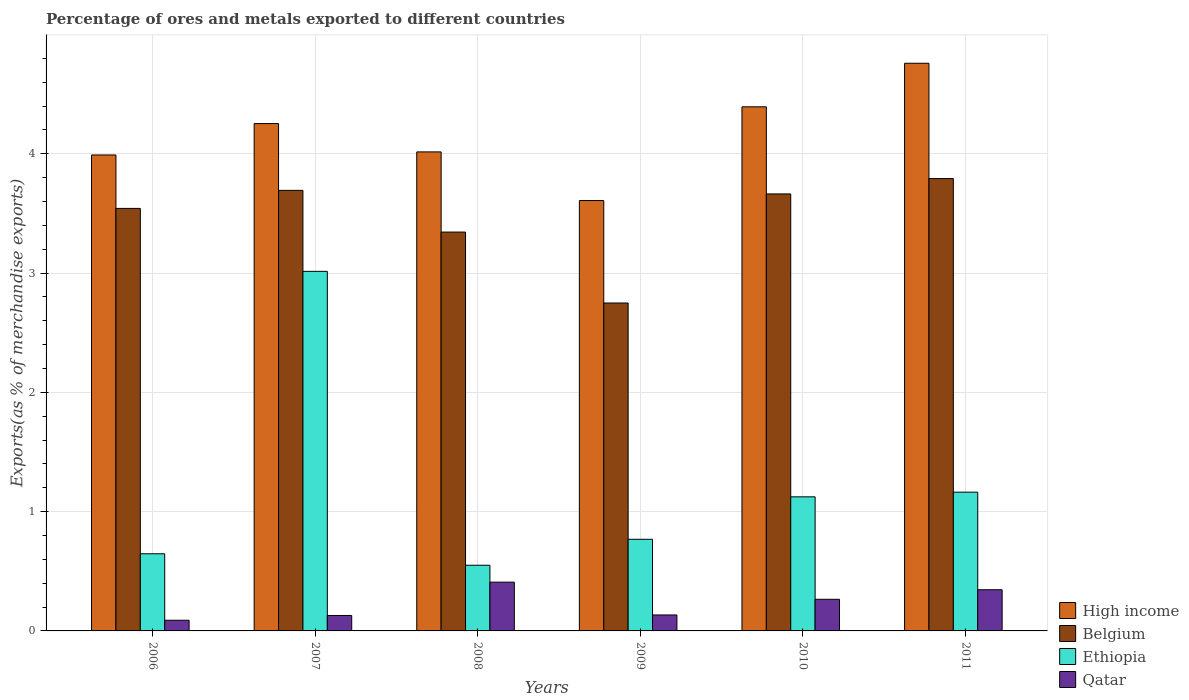Are the number of bars per tick equal to the number of legend labels?
Offer a terse response. Yes. How many bars are there on the 6th tick from the left?
Keep it short and to the point. 4. In how many cases, is the number of bars for a given year not equal to the number of legend labels?
Give a very brief answer. 0. What is the percentage of exports to different countries in High income in 2009?
Offer a very short reply. 3.61. Across all years, what is the maximum percentage of exports to different countries in High income?
Provide a succinct answer. 4.76. Across all years, what is the minimum percentage of exports to different countries in Belgium?
Your answer should be very brief. 2.75. What is the total percentage of exports to different countries in Belgium in the graph?
Give a very brief answer. 20.78. What is the difference between the percentage of exports to different countries in High income in 2006 and that in 2009?
Make the answer very short. 0.38. What is the difference between the percentage of exports to different countries in Belgium in 2007 and the percentage of exports to different countries in Ethiopia in 2006?
Offer a terse response. 3.05. What is the average percentage of exports to different countries in High income per year?
Ensure brevity in your answer.  4.17. In the year 2006, what is the difference between the percentage of exports to different countries in Qatar and percentage of exports to different countries in Ethiopia?
Provide a short and direct response. -0.56. In how many years, is the percentage of exports to different countries in Qatar greater than 4.2 %?
Your response must be concise. 0. What is the ratio of the percentage of exports to different countries in Belgium in 2007 to that in 2008?
Give a very brief answer. 1.1. Is the percentage of exports to different countries in Qatar in 2007 less than that in 2010?
Your answer should be very brief. Yes. What is the difference between the highest and the second highest percentage of exports to different countries in High income?
Ensure brevity in your answer.  0.37. What is the difference between the highest and the lowest percentage of exports to different countries in Ethiopia?
Your response must be concise. 2.46. What does the 2nd bar from the right in 2011 represents?
Provide a succinct answer. Ethiopia. Are all the bars in the graph horizontal?
Keep it short and to the point. No. How many years are there in the graph?
Your response must be concise. 6. What is the difference between two consecutive major ticks on the Y-axis?
Provide a succinct answer. 1. Are the values on the major ticks of Y-axis written in scientific E-notation?
Provide a succinct answer. No. Does the graph contain any zero values?
Give a very brief answer. No. How are the legend labels stacked?
Keep it short and to the point. Vertical. What is the title of the graph?
Ensure brevity in your answer.  Percentage of ores and metals exported to different countries. What is the label or title of the X-axis?
Give a very brief answer. Years. What is the label or title of the Y-axis?
Offer a terse response. Exports(as % of merchandise exports). What is the Exports(as % of merchandise exports) in High income in 2006?
Your response must be concise. 3.99. What is the Exports(as % of merchandise exports) of Belgium in 2006?
Offer a very short reply. 3.54. What is the Exports(as % of merchandise exports) of Ethiopia in 2006?
Your response must be concise. 0.65. What is the Exports(as % of merchandise exports) in Qatar in 2006?
Your response must be concise. 0.09. What is the Exports(as % of merchandise exports) of High income in 2007?
Offer a very short reply. 4.25. What is the Exports(as % of merchandise exports) of Belgium in 2007?
Your answer should be compact. 3.69. What is the Exports(as % of merchandise exports) in Ethiopia in 2007?
Offer a terse response. 3.01. What is the Exports(as % of merchandise exports) in Qatar in 2007?
Your answer should be compact. 0.13. What is the Exports(as % of merchandise exports) in High income in 2008?
Offer a very short reply. 4.02. What is the Exports(as % of merchandise exports) of Belgium in 2008?
Give a very brief answer. 3.34. What is the Exports(as % of merchandise exports) in Ethiopia in 2008?
Give a very brief answer. 0.55. What is the Exports(as % of merchandise exports) in Qatar in 2008?
Provide a succinct answer. 0.41. What is the Exports(as % of merchandise exports) in High income in 2009?
Keep it short and to the point. 3.61. What is the Exports(as % of merchandise exports) in Belgium in 2009?
Provide a short and direct response. 2.75. What is the Exports(as % of merchandise exports) in Ethiopia in 2009?
Your answer should be compact. 0.77. What is the Exports(as % of merchandise exports) in Qatar in 2009?
Keep it short and to the point. 0.13. What is the Exports(as % of merchandise exports) of High income in 2010?
Provide a succinct answer. 4.39. What is the Exports(as % of merchandise exports) of Belgium in 2010?
Your answer should be compact. 3.66. What is the Exports(as % of merchandise exports) in Ethiopia in 2010?
Ensure brevity in your answer.  1.12. What is the Exports(as % of merchandise exports) in Qatar in 2010?
Offer a very short reply. 0.27. What is the Exports(as % of merchandise exports) in High income in 2011?
Make the answer very short. 4.76. What is the Exports(as % of merchandise exports) of Belgium in 2011?
Keep it short and to the point. 3.79. What is the Exports(as % of merchandise exports) of Ethiopia in 2011?
Give a very brief answer. 1.16. What is the Exports(as % of merchandise exports) of Qatar in 2011?
Ensure brevity in your answer.  0.35. Across all years, what is the maximum Exports(as % of merchandise exports) of High income?
Your answer should be very brief. 4.76. Across all years, what is the maximum Exports(as % of merchandise exports) of Belgium?
Provide a succinct answer. 3.79. Across all years, what is the maximum Exports(as % of merchandise exports) of Ethiopia?
Your answer should be compact. 3.01. Across all years, what is the maximum Exports(as % of merchandise exports) of Qatar?
Your answer should be very brief. 0.41. Across all years, what is the minimum Exports(as % of merchandise exports) of High income?
Give a very brief answer. 3.61. Across all years, what is the minimum Exports(as % of merchandise exports) of Belgium?
Give a very brief answer. 2.75. Across all years, what is the minimum Exports(as % of merchandise exports) in Ethiopia?
Your response must be concise. 0.55. Across all years, what is the minimum Exports(as % of merchandise exports) in Qatar?
Ensure brevity in your answer.  0.09. What is the total Exports(as % of merchandise exports) in High income in the graph?
Your answer should be compact. 25.02. What is the total Exports(as % of merchandise exports) of Belgium in the graph?
Keep it short and to the point. 20.78. What is the total Exports(as % of merchandise exports) in Ethiopia in the graph?
Provide a succinct answer. 7.27. What is the total Exports(as % of merchandise exports) in Qatar in the graph?
Make the answer very short. 1.37. What is the difference between the Exports(as % of merchandise exports) in High income in 2006 and that in 2007?
Offer a very short reply. -0.26. What is the difference between the Exports(as % of merchandise exports) in Belgium in 2006 and that in 2007?
Your response must be concise. -0.15. What is the difference between the Exports(as % of merchandise exports) in Ethiopia in 2006 and that in 2007?
Offer a very short reply. -2.37. What is the difference between the Exports(as % of merchandise exports) in Qatar in 2006 and that in 2007?
Provide a succinct answer. -0.04. What is the difference between the Exports(as % of merchandise exports) in High income in 2006 and that in 2008?
Your answer should be very brief. -0.03. What is the difference between the Exports(as % of merchandise exports) of Belgium in 2006 and that in 2008?
Your answer should be very brief. 0.2. What is the difference between the Exports(as % of merchandise exports) of Ethiopia in 2006 and that in 2008?
Provide a succinct answer. 0.1. What is the difference between the Exports(as % of merchandise exports) of Qatar in 2006 and that in 2008?
Provide a short and direct response. -0.32. What is the difference between the Exports(as % of merchandise exports) in High income in 2006 and that in 2009?
Your answer should be very brief. 0.38. What is the difference between the Exports(as % of merchandise exports) in Belgium in 2006 and that in 2009?
Give a very brief answer. 0.79. What is the difference between the Exports(as % of merchandise exports) of Ethiopia in 2006 and that in 2009?
Give a very brief answer. -0.12. What is the difference between the Exports(as % of merchandise exports) of Qatar in 2006 and that in 2009?
Provide a short and direct response. -0.04. What is the difference between the Exports(as % of merchandise exports) of High income in 2006 and that in 2010?
Make the answer very short. -0.4. What is the difference between the Exports(as % of merchandise exports) of Belgium in 2006 and that in 2010?
Your response must be concise. -0.12. What is the difference between the Exports(as % of merchandise exports) of Ethiopia in 2006 and that in 2010?
Give a very brief answer. -0.48. What is the difference between the Exports(as % of merchandise exports) of Qatar in 2006 and that in 2010?
Provide a succinct answer. -0.18. What is the difference between the Exports(as % of merchandise exports) of High income in 2006 and that in 2011?
Give a very brief answer. -0.77. What is the difference between the Exports(as % of merchandise exports) in Belgium in 2006 and that in 2011?
Your answer should be compact. -0.25. What is the difference between the Exports(as % of merchandise exports) of Ethiopia in 2006 and that in 2011?
Ensure brevity in your answer.  -0.52. What is the difference between the Exports(as % of merchandise exports) in Qatar in 2006 and that in 2011?
Offer a very short reply. -0.26. What is the difference between the Exports(as % of merchandise exports) of High income in 2007 and that in 2008?
Keep it short and to the point. 0.24. What is the difference between the Exports(as % of merchandise exports) of Belgium in 2007 and that in 2008?
Give a very brief answer. 0.35. What is the difference between the Exports(as % of merchandise exports) in Ethiopia in 2007 and that in 2008?
Keep it short and to the point. 2.46. What is the difference between the Exports(as % of merchandise exports) in Qatar in 2007 and that in 2008?
Provide a short and direct response. -0.28. What is the difference between the Exports(as % of merchandise exports) in High income in 2007 and that in 2009?
Provide a succinct answer. 0.65. What is the difference between the Exports(as % of merchandise exports) of Belgium in 2007 and that in 2009?
Offer a terse response. 0.94. What is the difference between the Exports(as % of merchandise exports) in Ethiopia in 2007 and that in 2009?
Ensure brevity in your answer.  2.25. What is the difference between the Exports(as % of merchandise exports) in Qatar in 2007 and that in 2009?
Provide a short and direct response. -0. What is the difference between the Exports(as % of merchandise exports) of High income in 2007 and that in 2010?
Your answer should be very brief. -0.14. What is the difference between the Exports(as % of merchandise exports) of Belgium in 2007 and that in 2010?
Your response must be concise. 0.03. What is the difference between the Exports(as % of merchandise exports) in Ethiopia in 2007 and that in 2010?
Provide a succinct answer. 1.89. What is the difference between the Exports(as % of merchandise exports) in Qatar in 2007 and that in 2010?
Provide a succinct answer. -0.14. What is the difference between the Exports(as % of merchandise exports) of High income in 2007 and that in 2011?
Keep it short and to the point. -0.51. What is the difference between the Exports(as % of merchandise exports) of Belgium in 2007 and that in 2011?
Your answer should be compact. -0.1. What is the difference between the Exports(as % of merchandise exports) of Ethiopia in 2007 and that in 2011?
Give a very brief answer. 1.85. What is the difference between the Exports(as % of merchandise exports) of Qatar in 2007 and that in 2011?
Your answer should be compact. -0.22. What is the difference between the Exports(as % of merchandise exports) in High income in 2008 and that in 2009?
Your response must be concise. 0.41. What is the difference between the Exports(as % of merchandise exports) of Belgium in 2008 and that in 2009?
Offer a very short reply. 0.59. What is the difference between the Exports(as % of merchandise exports) in Ethiopia in 2008 and that in 2009?
Keep it short and to the point. -0.22. What is the difference between the Exports(as % of merchandise exports) of Qatar in 2008 and that in 2009?
Ensure brevity in your answer.  0.28. What is the difference between the Exports(as % of merchandise exports) in High income in 2008 and that in 2010?
Your answer should be very brief. -0.38. What is the difference between the Exports(as % of merchandise exports) in Belgium in 2008 and that in 2010?
Offer a terse response. -0.32. What is the difference between the Exports(as % of merchandise exports) of Ethiopia in 2008 and that in 2010?
Keep it short and to the point. -0.57. What is the difference between the Exports(as % of merchandise exports) in Qatar in 2008 and that in 2010?
Make the answer very short. 0.14. What is the difference between the Exports(as % of merchandise exports) in High income in 2008 and that in 2011?
Your answer should be very brief. -0.74. What is the difference between the Exports(as % of merchandise exports) of Belgium in 2008 and that in 2011?
Make the answer very short. -0.45. What is the difference between the Exports(as % of merchandise exports) in Ethiopia in 2008 and that in 2011?
Your answer should be very brief. -0.61. What is the difference between the Exports(as % of merchandise exports) of Qatar in 2008 and that in 2011?
Provide a succinct answer. 0.06. What is the difference between the Exports(as % of merchandise exports) of High income in 2009 and that in 2010?
Provide a short and direct response. -0.79. What is the difference between the Exports(as % of merchandise exports) of Belgium in 2009 and that in 2010?
Give a very brief answer. -0.91. What is the difference between the Exports(as % of merchandise exports) of Ethiopia in 2009 and that in 2010?
Give a very brief answer. -0.36. What is the difference between the Exports(as % of merchandise exports) in Qatar in 2009 and that in 2010?
Your answer should be compact. -0.13. What is the difference between the Exports(as % of merchandise exports) in High income in 2009 and that in 2011?
Provide a short and direct response. -1.15. What is the difference between the Exports(as % of merchandise exports) of Belgium in 2009 and that in 2011?
Offer a terse response. -1.04. What is the difference between the Exports(as % of merchandise exports) in Ethiopia in 2009 and that in 2011?
Offer a terse response. -0.4. What is the difference between the Exports(as % of merchandise exports) in Qatar in 2009 and that in 2011?
Your answer should be very brief. -0.21. What is the difference between the Exports(as % of merchandise exports) of High income in 2010 and that in 2011?
Make the answer very short. -0.37. What is the difference between the Exports(as % of merchandise exports) in Belgium in 2010 and that in 2011?
Your answer should be compact. -0.13. What is the difference between the Exports(as % of merchandise exports) of Ethiopia in 2010 and that in 2011?
Make the answer very short. -0.04. What is the difference between the Exports(as % of merchandise exports) of Qatar in 2010 and that in 2011?
Give a very brief answer. -0.08. What is the difference between the Exports(as % of merchandise exports) of High income in 2006 and the Exports(as % of merchandise exports) of Belgium in 2007?
Your response must be concise. 0.3. What is the difference between the Exports(as % of merchandise exports) in High income in 2006 and the Exports(as % of merchandise exports) in Ethiopia in 2007?
Ensure brevity in your answer.  0.98. What is the difference between the Exports(as % of merchandise exports) of High income in 2006 and the Exports(as % of merchandise exports) of Qatar in 2007?
Your answer should be very brief. 3.86. What is the difference between the Exports(as % of merchandise exports) of Belgium in 2006 and the Exports(as % of merchandise exports) of Ethiopia in 2007?
Ensure brevity in your answer.  0.53. What is the difference between the Exports(as % of merchandise exports) of Belgium in 2006 and the Exports(as % of merchandise exports) of Qatar in 2007?
Make the answer very short. 3.41. What is the difference between the Exports(as % of merchandise exports) in Ethiopia in 2006 and the Exports(as % of merchandise exports) in Qatar in 2007?
Your response must be concise. 0.52. What is the difference between the Exports(as % of merchandise exports) in High income in 2006 and the Exports(as % of merchandise exports) in Belgium in 2008?
Offer a very short reply. 0.65. What is the difference between the Exports(as % of merchandise exports) in High income in 2006 and the Exports(as % of merchandise exports) in Ethiopia in 2008?
Provide a succinct answer. 3.44. What is the difference between the Exports(as % of merchandise exports) in High income in 2006 and the Exports(as % of merchandise exports) in Qatar in 2008?
Provide a succinct answer. 3.58. What is the difference between the Exports(as % of merchandise exports) of Belgium in 2006 and the Exports(as % of merchandise exports) of Ethiopia in 2008?
Keep it short and to the point. 2.99. What is the difference between the Exports(as % of merchandise exports) in Belgium in 2006 and the Exports(as % of merchandise exports) in Qatar in 2008?
Your response must be concise. 3.13. What is the difference between the Exports(as % of merchandise exports) in Ethiopia in 2006 and the Exports(as % of merchandise exports) in Qatar in 2008?
Your response must be concise. 0.24. What is the difference between the Exports(as % of merchandise exports) in High income in 2006 and the Exports(as % of merchandise exports) in Belgium in 2009?
Provide a short and direct response. 1.24. What is the difference between the Exports(as % of merchandise exports) of High income in 2006 and the Exports(as % of merchandise exports) of Ethiopia in 2009?
Offer a terse response. 3.22. What is the difference between the Exports(as % of merchandise exports) in High income in 2006 and the Exports(as % of merchandise exports) in Qatar in 2009?
Offer a very short reply. 3.86. What is the difference between the Exports(as % of merchandise exports) in Belgium in 2006 and the Exports(as % of merchandise exports) in Ethiopia in 2009?
Your answer should be very brief. 2.77. What is the difference between the Exports(as % of merchandise exports) of Belgium in 2006 and the Exports(as % of merchandise exports) of Qatar in 2009?
Give a very brief answer. 3.41. What is the difference between the Exports(as % of merchandise exports) in Ethiopia in 2006 and the Exports(as % of merchandise exports) in Qatar in 2009?
Ensure brevity in your answer.  0.51. What is the difference between the Exports(as % of merchandise exports) of High income in 2006 and the Exports(as % of merchandise exports) of Belgium in 2010?
Offer a terse response. 0.33. What is the difference between the Exports(as % of merchandise exports) of High income in 2006 and the Exports(as % of merchandise exports) of Ethiopia in 2010?
Give a very brief answer. 2.87. What is the difference between the Exports(as % of merchandise exports) in High income in 2006 and the Exports(as % of merchandise exports) in Qatar in 2010?
Make the answer very short. 3.72. What is the difference between the Exports(as % of merchandise exports) in Belgium in 2006 and the Exports(as % of merchandise exports) in Ethiopia in 2010?
Ensure brevity in your answer.  2.42. What is the difference between the Exports(as % of merchandise exports) of Belgium in 2006 and the Exports(as % of merchandise exports) of Qatar in 2010?
Your response must be concise. 3.28. What is the difference between the Exports(as % of merchandise exports) in Ethiopia in 2006 and the Exports(as % of merchandise exports) in Qatar in 2010?
Keep it short and to the point. 0.38. What is the difference between the Exports(as % of merchandise exports) of High income in 2006 and the Exports(as % of merchandise exports) of Belgium in 2011?
Your response must be concise. 0.2. What is the difference between the Exports(as % of merchandise exports) in High income in 2006 and the Exports(as % of merchandise exports) in Ethiopia in 2011?
Offer a very short reply. 2.83. What is the difference between the Exports(as % of merchandise exports) in High income in 2006 and the Exports(as % of merchandise exports) in Qatar in 2011?
Offer a very short reply. 3.64. What is the difference between the Exports(as % of merchandise exports) in Belgium in 2006 and the Exports(as % of merchandise exports) in Ethiopia in 2011?
Provide a short and direct response. 2.38. What is the difference between the Exports(as % of merchandise exports) of Belgium in 2006 and the Exports(as % of merchandise exports) of Qatar in 2011?
Provide a short and direct response. 3.2. What is the difference between the Exports(as % of merchandise exports) in Ethiopia in 2006 and the Exports(as % of merchandise exports) in Qatar in 2011?
Provide a short and direct response. 0.3. What is the difference between the Exports(as % of merchandise exports) in High income in 2007 and the Exports(as % of merchandise exports) in Belgium in 2008?
Ensure brevity in your answer.  0.91. What is the difference between the Exports(as % of merchandise exports) of High income in 2007 and the Exports(as % of merchandise exports) of Ethiopia in 2008?
Offer a very short reply. 3.7. What is the difference between the Exports(as % of merchandise exports) of High income in 2007 and the Exports(as % of merchandise exports) of Qatar in 2008?
Provide a short and direct response. 3.84. What is the difference between the Exports(as % of merchandise exports) of Belgium in 2007 and the Exports(as % of merchandise exports) of Ethiopia in 2008?
Provide a short and direct response. 3.14. What is the difference between the Exports(as % of merchandise exports) of Belgium in 2007 and the Exports(as % of merchandise exports) of Qatar in 2008?
Your answer should be compact. 3.28. What is the difference between the Exports(as % of merchandise exports) in Ethiopia in 2007 and the Exports(as % of merchandise exports) in Qatar in 2008?
Offer a terse response. 2.61. What is the difference between the Exports(as % of merchandise exports) of High income in 2007 and the Exports(as % of merchandise exports) of Belgium in 2009?
Make the answer very short. 1.5. What is the difference between the Exports(as % of merchandise exports) in High income in 2007 and the Exports(as % of merchandise exports) in Ethiopia in 2009?
Your answer should be compact. 3.48. What is the difference between the Exports(as % of merchandise exports) of High income in 2007 and the Exports(as % of merchandise exports) of Qatar in 2009?
Your response must be concise. 4.12. What is the difference between the Exports(as % of merchandise exports) of Belgium in 2007 and the Exports(as % of merchandise exports) of Ethiopia in 2009?
Provide a short and direct response. 2.92. What is the difference between the Exports(as % of merchandise exports) in Belgium in 2007 and the Exports(as % of merchandise exports) in Qatar in 2009?
Ensure brevity in your answer.  3.56. What is the difference between the Exports(as % of merchandise exports) of Ethiopia in 2007 and the Exports(as % of merchandise exports) of Qatar in 2009?
Offer a terse response. 2.88. What is the difference between the Exports(as % of merchandise exports) in High income in 2007 and the Exports(as % of merchandise exports) in Belgium in 2010?
Give a very brief answer. 0.59. What is the difference between the Exports(as % of merchandise exports) of High income in 2007 and the Exports(as % of merchandise exports) of Ethiopia in 2010?
Offer a very short reply. 3.13. What is the difference between the Exports(as % of merchandise exports) in High income in 2007 and the Exports(as % of merchandise exports) in Qatar in 2010?
Provide a short and direct response. 3.99. What is the difference between the Exports(as % of merchandise exports) in Belgium in 2007 and the Exports(as % of merchandise exports) in Ethiopia in 2010?
Offer a terse response. 2.57. What is the difference between the Exports(as % of merchandise exports) of Belgium in 2007 and the Exports(as % of merchandise exports) of Qatar in 2010?
Your response must be concise. 3.43. What is the difference between the Exports(as % of merchandise exports) of Ethiopia in 2007 and the Exports(as % of merchandise exports) of Qatar in 2010?
Your answer should be very brief. 2.75. What is the difference between the Exports(as % of merchandise exports) of High income in 2007 and the Exports(as % of merchandise exports) of Belgium in 2011?
Provide a succinct answer. 0.46. What is the difference between the Exports(as % of merchandise exports) of High income in 2007 and the Exports(as % of merchandise exports) of Ethiopia in 2011?
Ensure brevity in your answer.  3.09. What is the difference between the Exports(as % of merchandise exports) in High income in 2007 and the Exports(as % of merchandise exports) in Qatar in 2011?
Offer a terse response. 3.91. What is the difference between the Exports(as % of merchandise exports) of Belgium in 2007 and the Exports(as % of merchandise exports) of Ethiopia in 2011?
Offer a very short reply. 2.53. What is the difference between the Exports(as % of merchandise exports) of Belgium in 2007 and the Exports(as % of merchandise exports) of Qatar in 2011?
Offer a very short reply. 3.35. What is the difference between the Exports(as % of merchandise exports) in Ethiopia in 2007 and the Exports(as % of merchandise exports) in Qatar in 2011?
Ensure brevity in your answer.  2.67. What is the difference between the Exports(as % of merchandise exports) of High income in 2008 and the Exports(as % of merchandise exports) of Belgium in 2009?
Ensure brevity in your answer.  1.27. What is the difference between the Exports(as % of merchandise exports) in High income in 2008 and the Exports(as % of merchandise exports) in Ethiopia in 2009?
Give a very brief answer. 3.25. What is the difference between the Exports(as % of merchandise exports) in High income in 2008 and the Exports(as % of merchandise exports) in Qatar in 2009?
Offer a very short reply. 3.88. What is the difference between the Exports(as % of merchandise exports) of Belgium in 2008 and the Exports(as % of merchandise exports) of Ethiopia in 2009?
Provide a succinct answer. 2.58. What is the difference between the Exports(as % of merchandise exports) of Belgium in 2008 and the Exports(as % of merchandise exports) of Qatar in 2009?
Your response must be concise. 3.21. What is the difference between the Exports(as % of merchandise exports) of Ethiopia in 2008 and the Exports(as % of merchandise exports) of Qatar in 2009?
Your answer should be very brief. 0.42. What is the difference between the Exports(as % of merchandise exports) in High income in 2008 and the Exports(as % of merchandise exports) in Belgium in 2010?
Provide a short and direct response. 0.35. What is the difference between the Exports(as % of merchandise exports) in High income in 2008 and the Exports(as % of merchandise exports) in Ethiopia in 2010?
Your response must be concise. 2.89. What is the difference between the Exports(as % of merchandise exports) of High income in 2008 and the Exports(as % of merchandise exports) of Qatar in 2010?
Make the answer very short. 3.75. What is the difference between the Exports(as % of merchandise exports) in Belgium in 2008 and the Exports(as % of merchandise exports) in Ethiopia in 2010?
Offer a terse response. 2.22. What is the difference between the Exports(as % of merchandise exports) of Belgium in 2008 and the Exports(as % of merchandise exports) of Qatar in 2010?
Your response must be concise. 3.08. What is the difference between the Exports(as % of merchandise exports) of Ethiopia in 2008 and the Exports(as % of merchandise exports) of Qatar in 2010?
Offer a very short reply. 0.29. What is the difference between the Exports(as % of merchandise exports) in High income in 2008 and the Exports(as % of merchandise exports) in Belgium in 2011?
Give a very brief answer. 0.22. What is the difference between the Exports(as % of merchandise exports) of High income in 2008 and the Exports(as % of merchandise exports) of Ethiopia in 2011?
Provide a succinct answer. 2.85. What is the difference between the Exports(as % of merchandise exports) of High income in 2008 and the Exports(as % of merchandise exports) of Qatar in 2011?
Provide a short and direct response. 3.67. What is the difference between the Exports(as % of merchandise exports) of Belgium in 2008 and the Exports(as % of merchandise exports) of Ethiopia in 2011?
Offer a very short reply. 2.18. What is the difference between the Exports(as % of merchandise exports) of Belgium in 2008 and the Exports(as % of merchandise exports) of Qatar in 2011?
Offer a terse response. 3. What is the difference between the Exports(as % of merchandise exports) of Ethiopia in 2008 and the Exports(as % of merchandise exports) of Qatar in 2011?
Keep it short and to the point. 0.21. What is the difference between the Exports(as % of merchandise exports) of High income in 2009 and the Exports(as % of merchandise exports) of Belgium in 2010?
Your answer should be compact. -0.06. What is the difference between the Exports(as % of merchandise exports) in High income in 2009 and the Exports(as % of merchandise exports) in Ethiopia in 2010?
Provide a succinct answer. 2.48. What is the difference between the Exports(as % of merchandise exports) in High income in 2009 and the Exports(as % of merchandise exports) in Qatar in 2010?
Your response must be concise. 3.34. What is the difference between the Exports(as % of merchandise exports) of Belgium in 2009 and the Exports(as % of merchandise exports) of Ethiopia in 2010?
Your answer should be very brief. 1.62. What is the difference between the Exports(as % of merchandise exports) of Belgium in 2009 and the Exports(as % of merchandise exports) of Qatar in 2010?
Give a very brief answer. 2.48. What is the difference between the Exports(as % of merchandise exports) of Ethiopia in 2009 and the Exports(as % of merchandise exports) of Qatar in 2010?
Provide a short and direct response. 0.5. What is the difference between the Exports(as % of merchandise exports) of High income in 2009 and the Exports(as % of merchandise exports) of Belgium in 2011?
Offer a terse response. -0.18. What is the difference between the Exports(as % of merchandise exports) in High income in 2009 and the Exports(as % of merchandise exports) in Ethiopia in 2011?
Ensure brevity in your answer.  2.44. What is the difference between the Exports(as % of merchandise exports) in High income in 2009 and the Exports(as % of merchandise exports) in Qatar in 2011?
Provide a short and direct response. 3.26. What is the difference between the Exports(as % of merchandise exports) of Belgium in 2009 and the Exports(as % of merchandise exports) of Ethiopia in 2011?
Keep it short and to the point. 1.59. What is the difference between the Exports(as % of merchandise exports) of Belgium in 2009 and the Exports(as % of merchandise exports) of Qatar in 2011?
Give a very brief answer. 2.4. What is the difference between the Exports(as % of merchandise exports) in Ethiopia in 2009 and the Exports(as % of merchandise exports) in Qatar in 2011?
Keep it short and to the point. 0.42. What is the difference between the Exports(as % of merchandise exports) of High income in 2010 and the Exports(as % of merchandise exports) of Belgium in 2011?
Provide a succinct answer. 0.6. What is the difference between the Exports(as % of merchandise exports) of High income in 2010 and the Exports(as % of merchandise exports) of Ethiopia in 2011?
Offer a terse response. 3.23. What is the difference between the Exports(as % of merchandise exports) in High income in 2010 and the Exports(as % of merchandise exports) in Qatar in 2011?
Give a very brief answer. 4.05. What is the difference between the Exports(as % of merchandise exports) in Belgium in 2010 and the Exports(as % of merchandise exports) in Ethiopia in 2011?
Your response must be concise. 2.5. What is the difference between the Exports(as % of merchandise exports) in Belgium in 2010 and the Exports(as % of merchandise exports) in Qatar in 2011?
Offer a terse response. 3.32. What is the difference between the Exports(as % of merchandise exports) in Ethiopia in 2010 and the Exports(as % of merchandise exports) in Qatar in 2011?
Your response must be concise. 0.78. What is the average Exports(as % of merchandise exports) in High income per year?
Offer a very short reply. 4.17. What is the average Exports(as % of merchandise exports) of Belgium per year?
Ensure brevity in your answer.  3.46. What is the average Exports(as % of merchandise exports) in Ethiopia per year?
Your answer should be compact. 1.21. What is the average Exports(as % of merchandise exports) in Qatar per year?
Provide a short and direct response. 0.23. In the year 2006, what is the difference between the Exports(as % of merchandise exports) in High income and Exports(as % of merchandise exports) in Belgium?
Offer a terse response. 0.45. In the year 2006, what is the difference between the Exports(as % of merchandise exports) in High income and Exports(as % of merchandise exports) in Ethiopia?
Offer a very short reply. 3.34. In the year 2006, what is the difference between the Exports(as % of merchandise exports) of High income and Exports(as % of merchandise exports) of Qatar?
Your answer should be very brief. 3.9. In the year 2006, what is the difference between the Exports(as % of merchandise exports) of Belgium and Exports(as % of merchandise exports) of Ethiopia?
Your answer should be very brief. 2.9. In the year 2006, what is the difference between the Exports(as % of merchandise exports) of Belgium and Exports(as % of merchandise exports) of Qatar?
Keep it short and to the point. 3.45. In the year 2006, what is the difference between the Exports(as % of merchandise exports) of Ethiopia and Exports(as % of merchandise exports) of Qatar?
Keep it short and to the point. 0.56. In the year 2007, what is the difference between the Exports(as % of merchandise exports) of High income and Exports(as % of merchandise exports) of Belgium?
Provide a succinct answer. 0.56. In the year 2007, what is the difference between the Exports(as % of merchandise exports) of High income and Exports(as % of merchandise exports) of Ethiopia?
Provide a short and direct response. 1.24. In the year 2007, what is the difference between the Exports(as % of merchandise exports) of High income and Exports(as % of merchandise exports) of Qatar?
Offer a terse response. 4.12. In the year 2007, what is the difference between the Exports(as % of merchandise exports) of Belgium and Exports(as % of merchandise exports) of Ethiopia?
Keep it short and to the point. 0.68. In the year 2007, what is the difference between the Exports(as % of merchandise exports) of Belgium and Exports(as % of merchandise exports) of Qatar?
Your answer should be compact. 3.56. In the year 2007, what is the difference between the Exports(as % of merchandise exports) in Ethiopia and Exports(as % of merchandise exports) in Qatar?
Offer a very short reply. 2.88. In the year 2008, what is the difference between the Exports(as % of merchandise exports) in High income and Exports(as % of merchandise exports) in Belgium?
Give a very brief answer. 0.67. In the year 2008, what is the difference between the Exports(as % of merchandise exports) of High income and Exports(as % of merchandise exports) of Ethiopia?
Your response must be concise. 3.46. In the year 2008, what is the difference between the Exports(as % of merchandise exports) of High income and Exports(as % of merchandise exports) of Qatar?
Make the answer very short. 3.61. In the year 2008, what is the difference between the Exports(as % of merchandise exports) of Belgium and Exports(as % of merchandise exports) of Ethiopia?
Offer a very short reply. 2.79. In the year 2008, what is the difference between the Exports(as % of merchandise exports) in Belgium and Exports(as % of merchandise exports) in Qatar?
Provide a short and direct response. 2.93. In the year 2008, what is the difference between the Exports(as % of merchandise exports) of Ethiopia and Exports(as % of merchandise exports) of Qatar?
Make the answer very short. 0.14. In the year 2009, what is the difference between the Exports(as % of merchandise exports) of High income and Exports(as % of merchandise exports) of Belgium?
Ensure brevity in your answer.  0.86. In the year 2009, what is the difference between the Exports(as % of merchandise exports) of High income and Exports(as % of merchandise exports) of Ethiopia?
Your answer should be very brief. 2.84. In the year 2009, what is the difference between the Exports(as % of merchandise exports) in High income and Exports(as % of merchandise exports) in Qatar?
Your response must be concise. 3.47. In the year 2009, what is the difference between the Exports(as % of merchandise exports) in Belgium and Exports(as % of merchandise exports) in Ethiopia?
Your answer should be very brief. 1.98. In the year 2009, what is the difference between the Exports(as % of merchandise exports) in Belgium and Exports(as % of merchandise exports) in Qatar?
Give a very brief answer. 2.61. In the year 2009, what is the difference between the Exports(as % of merchandise exports) in Ethiopia and Exports(as % of merchandise exports) in Qatar?
Give a very brief answer. 0.63. In the year 2010, what is the difference between the Exports(as % of merchandise exports) of High income and Exports(as % of merchandise exports) of Belgium?
Your answer should be compact. 0.73. In the year 2010, what is the difference between the Exports(as % of merchandise exports) of High income and Exports(as % of merchandise exports) of Ethiopia?
Offer a very short reply. 3.27. In the year 2010, what is the difference between the Exports(as % of merchandise exports) in High income and Exports(as % of merchandise exports) in Qatar?
Your answer should be compact. 4.13. In the year 2010, what is the difference between the Exports(as % of merchandise exports) in Belgium and Exports(as % of merchandise exports) in Ethiopia?
Ensure brevity in your answer.  2.54. In the year 2010, what is the difference between the Exports(as % of merchandise exports) of Belgium and Exports(as % of merchandise exports) of Qatar?
Provide a short and direct response. 3.4. In the year 2010, what is the difference between the Exports(as % of merchandise exports) in Ethiopia and Exports(as % of merchandise exports) in Qatar?
Your answer should be compact. 0.86. In the year 2011, what is the difference between the Exports(as % of merchandise exports) in High income and Exports(as % of merchandise exports) in Belgium?
Provide a succinct answer. 0.97. In the year 2011, what is the difference between the Exports(as % of merchandise exports) of High income and Exports(as % of merchandise exports) of Ethiopia?
Make the answer very short. 3.6. In the year 2011, what is the difference between the Exports(as % of merchandise exports) of High income and Exports(as % of merchandise exports) of Qatar?
Ensure brevity in your answer.  4.41. In the year 2011, what is the difference between the Exports(as % of merchandise exports) of Belgium and Exports(as % of merchandise exports) of Ethiopia?
Provide a succinct answer. 2.63. In the year 2011, what is the difference between the Exports(as % of merchandise exports) in Belgium and Exports(as % of merchandise exports) in Qatar?
Your answer should be compact. 3.45. In the year 2011, what is the difference between the Exports(as % of merchandise exports) of Ethiopia and Exports(as % of merchandise exports) of Qatar?
Your answer should be very brief. 0.82. What is the ratio of the Exports(as % of merchandise exports) of High income in 2006 to that in 2007?
Make the answer very short. 0.94. What is the ratio of the Exports(as % of merchandise exports) of Belgium in 2006 to that in 2007?
Provide a short and direct response. 0.96. What is the ratio of the Exports(as % of merchandise exports) in Ethiopia in 2006 to that in 2007?
Provide a succinct answer. 0.21. What is the ratio of the Exports(as % of merchandise exports) of Qatar in 2006 to that in 2007?
Offer a very short reply. 0.69. What is the ratio of the Exports(as % of merchandise exports) of Belgium in 2006 to that in 2008?
Your answer should be compact. 1.06. What is the ratio of the Exports(as % of merchandise exports) in Ethiopia in 2006 to that in 2008?
Your answer should be compact. 1.17. What is the ratio of the Exports(as % of merchandise exports) in Qatar in 2006 to that in 2008?
Provide a succinct answer. 0.22. What is the ratio of the Exports(as % of merchandise exports) of High income in 2006 to that in 2009?
Your answer should be very brief. 1.11. What is the ratio of the Exports(as % of merchandise exports) of Belgium in 2006 to that in 2009?
Ensure brevity in your answer.  1.29. What is the ratio of the Exports(as % of merchandise exports) in Ethiopia in 2006 to that in 2009?
Provide a short and direct response. 0.84. What is the ratio of the Exports(as % of merchandise exports) of Qatar in 2006 to that in 2009?
Your answer should be very brief. 0.67. What is the ratio of the Exports(as % of merchandise exports) of High income in 2006 to that in 2010?
Offer a terse response. 0.91. What is the ratio of the Exports(as % of merchandise exports) of Belgium in 2006 to that in 2010?
Provide a succinct answer. 0.97. What is the ratio of the Exports(as % of merchandise exports) of Ethiopia in 2006 to that in 2010?
Make the answer very short. 0.58. What is the ratio of the Exports(as % of merchandise exports) in Qatar in 2006 to that in 2010?
Offer a very short reply. 0.34. What is the ratio of the Exports(as % of merchandise exports) in High income in 2006 to that in 2011?
Give a very brief answer. 0.84. What is the ratio of the Exports(as % of merchandise exports) in Belgium in 2006 to that in 2011?
Your response must be concise. 0.93. What is the ratio of the Exports(as % of merchandise exports) in Ethiopia in 2006 to that in 2011?
Give a very brief answer. 0.56. What is the ratio of the Exports(as % of merchandise exports) in Qatar in 2006 to that in 2011?
Make the answer very short. 0.26. What is the ratio of the Exports(as % of merchandise exports) of High income in 2007 to that in 2008?
Keep it short and to the point. 1.06. What is the ratio of the Exports(as % of merchandise exports) of Belgium in 2007 to that in 2008?
Ensure brevity in your answer.  1.1. What is the ratio of the Exports(as % of merchandise exports) of Ethiopia in 2007 to that in 2008?
Offer a terse response. 5.48. What is the ratio of the Exports(as % of merchandise exports) of Qatar in 2007 to that in 2008?
Your response must be concise. 0.32. What is the ratio of the Exports(as % of merchandise exports) in High income in 2007 to that in 2009?
Your answer should be compact. 1.18. What is the ratio of the Exports(as % of merchandise exports) of Belgium in 2007 to that in 2009?
Make the answer very short. 1.34. What is the ratio of the Exports(as % of merchandise exports) in Ethiopia in 2007 to that in 2009?
Make the answer very short. 3.92. What is the ratio of the Exports(as % of merchandise exports) in Qatar in 2007 to that in 2009?
Make the answer very short. 0.97. What is the ratio of the Exports(as % of merchandise exports) of High income in 2007 to that in 2010?
Your answer should be compact. 0.97. What is the ratio of the Exports(as % of merchandise exports) in Belgium in 2007 to that in 2010?
Your answer should be compact. 1.01. What is the ratio of the Exports(as % of merchandise exports) of Ethiopia in 2007 to that in 2010?
Make the answer very short. 2.68. What is the ratio of the Exports(as % of merchandise exports) in Qatar in 2007 to that in 2010?
Your answer should be compact. 0.49. What is the ratio of the Exports(as % of merchandise exports) in High income in 2007 to that in 2011?
Ensure brevity in your answer.  0.89. What is the ratio of the Exports(as % of merchandise exports) of Belgium in 2007 to that in 2011?
Give a very brief answer. 0.97. What is the ratio of the Exports(as % of merchandise exports) in Ethiopia in 2007 to that in 2011?
Keep it short and to the point. 2.59. What is the ratio of the Exports(as % of merchandise exports) in High income in 2008 to that in 2009?
Your response must be concise. 1.11. What is the ratio of the Exports(as % of merchandise exports) in Belgium in 2008 to that in 2009?
Your response must be concise. 1.22. What is the ratio of the Exports(as % of merchandise exports) of Ethiopia in 2008 to that in 2009?
Ensure brevity in your answer.  0.72. What is the ratio of the Exports(as % of merchandise exports) in Qatar in 2008 to that in 2009?
Offer a very short reply. 3.06. What is the ratio of the Exports(as % of merchandise exports) of High income in 2008 to that in 2010?
Make the answer very short. 0.91. What is the ratio of the Exports(as % of merchandise exports) in Belgium in 2008 to that in 2010?
Make the answer very short. 0.91. What is the ratio of the Exports(as % of merchandise exports) of Ethiopia in 2008 to that in 2010?
Provide a succinct answer. 0.49. What is the ratio of the Exports(as % of merchandise exports) in Qatar in 2008 to that in 2010?
Provide a succinct answer. 1.54. What is the ratio of the Exports(as % of merchandise exports) in High income in 2008 to that in 2011?
Offer a very short reply. 0.84. What is the ratio of the Exports(as % of merchandise exports) of Belgium in 2008 to that in 2011?
Offer a terse response. 0.88. What is the ratio of the Exports(as % of merchandise exports) of Ethiopia in 2008 to that in 2011?
Provide a succinct answer. 0.47. What is the ratio of the Exports(as % of merchandise exports) of Qatar in 2008 to that in 2011?
Give a very brief answer. 1.18. What is the ratio of the Exports(as % of merchandise exports) in High income in 2009 to that in 2010?
Make the answer very short. 0.82. What is the ratio of the Exports(as % of merchandise exports) in Belgium in 2009 to that in 2010?
Provide a short and direct response. 0.75. What is the ratio of the Exports(as % of merchandise exports) of Ethiopia in 2009 to that in 2010?
Provide a short and direct response. 0.68. What is the ratio of the Exports(as % of merchandise exports) of Qatar in 2009 to that in 2010?
Keep it short and to the point. 0.5. What is the ratio of the Exports(as % of merchandise exports) in High income in 2009 to that in 2011?
Your answer should be compact. 0.76. What is the ratio of the Exports(as % of merchandise exports) in Belgium in 2009 to that in 2011?
Ensure brevity in your answer.  0.72. What is the ratio of the Exports(as % of merchandise exports) of Ethiopia in 2009 to that in 2011?
Your response must be concise. 0.66. What is the ratio of the Exports(as % of merchandise exports) in Qatar in 2009 to that in 2011?
Your answer should be very brief. 0.39. What is the ratio of the Exports(as % of merchandise exports) in High income in 2010 to that in 2011?
Offer a very short reply. 0.92. What is the ratio of the Exports(as % of merchandise exports) in Ethiopia in 2010 to that in 2011?
Ensure brevity in your answer.  0.97. What is the ratio of the Exports(as % of merchandise exports) in Qatar in 2010 to that in 2011?
Provide a short and direct response. 0.77. What is the difference between the highest and the second highest Exports(as % of merchandise exports) of High income?
Your response must be concise. 0.37. What is the difference between the highest and the second highest Exports(as % of merchandise exports) in Belgium?
Give a very brief answer. 0.1. What is the difference between the highest and the second highest Exports(as % of merchandise exports) in Ethiopia?
Offer a very short reply. 1.85. What is the difference between the highest and the second highest Exports(as % of merchandise exports) of Qatar?
Ensure brevity in your answer.  0.06. What is the difference between the highest and the lowest Exports(as % of merchandise exports) in High income?
Provide a short and direct response. 1.15. What is the difference between the highest and the lowest Exports(as % of merchandise exports) in Belgium?
Your answer should be compact. 1.04. What is the difference between the highest and the lowest Exports(as % of merchandise exports) of Ethiopia?
Offer a terse response. 2.46. What is the difference between the highest and the lowest Exports(as % of merchandise exports) of Qatar?
Ensure brevity in your answer.  0.32. 